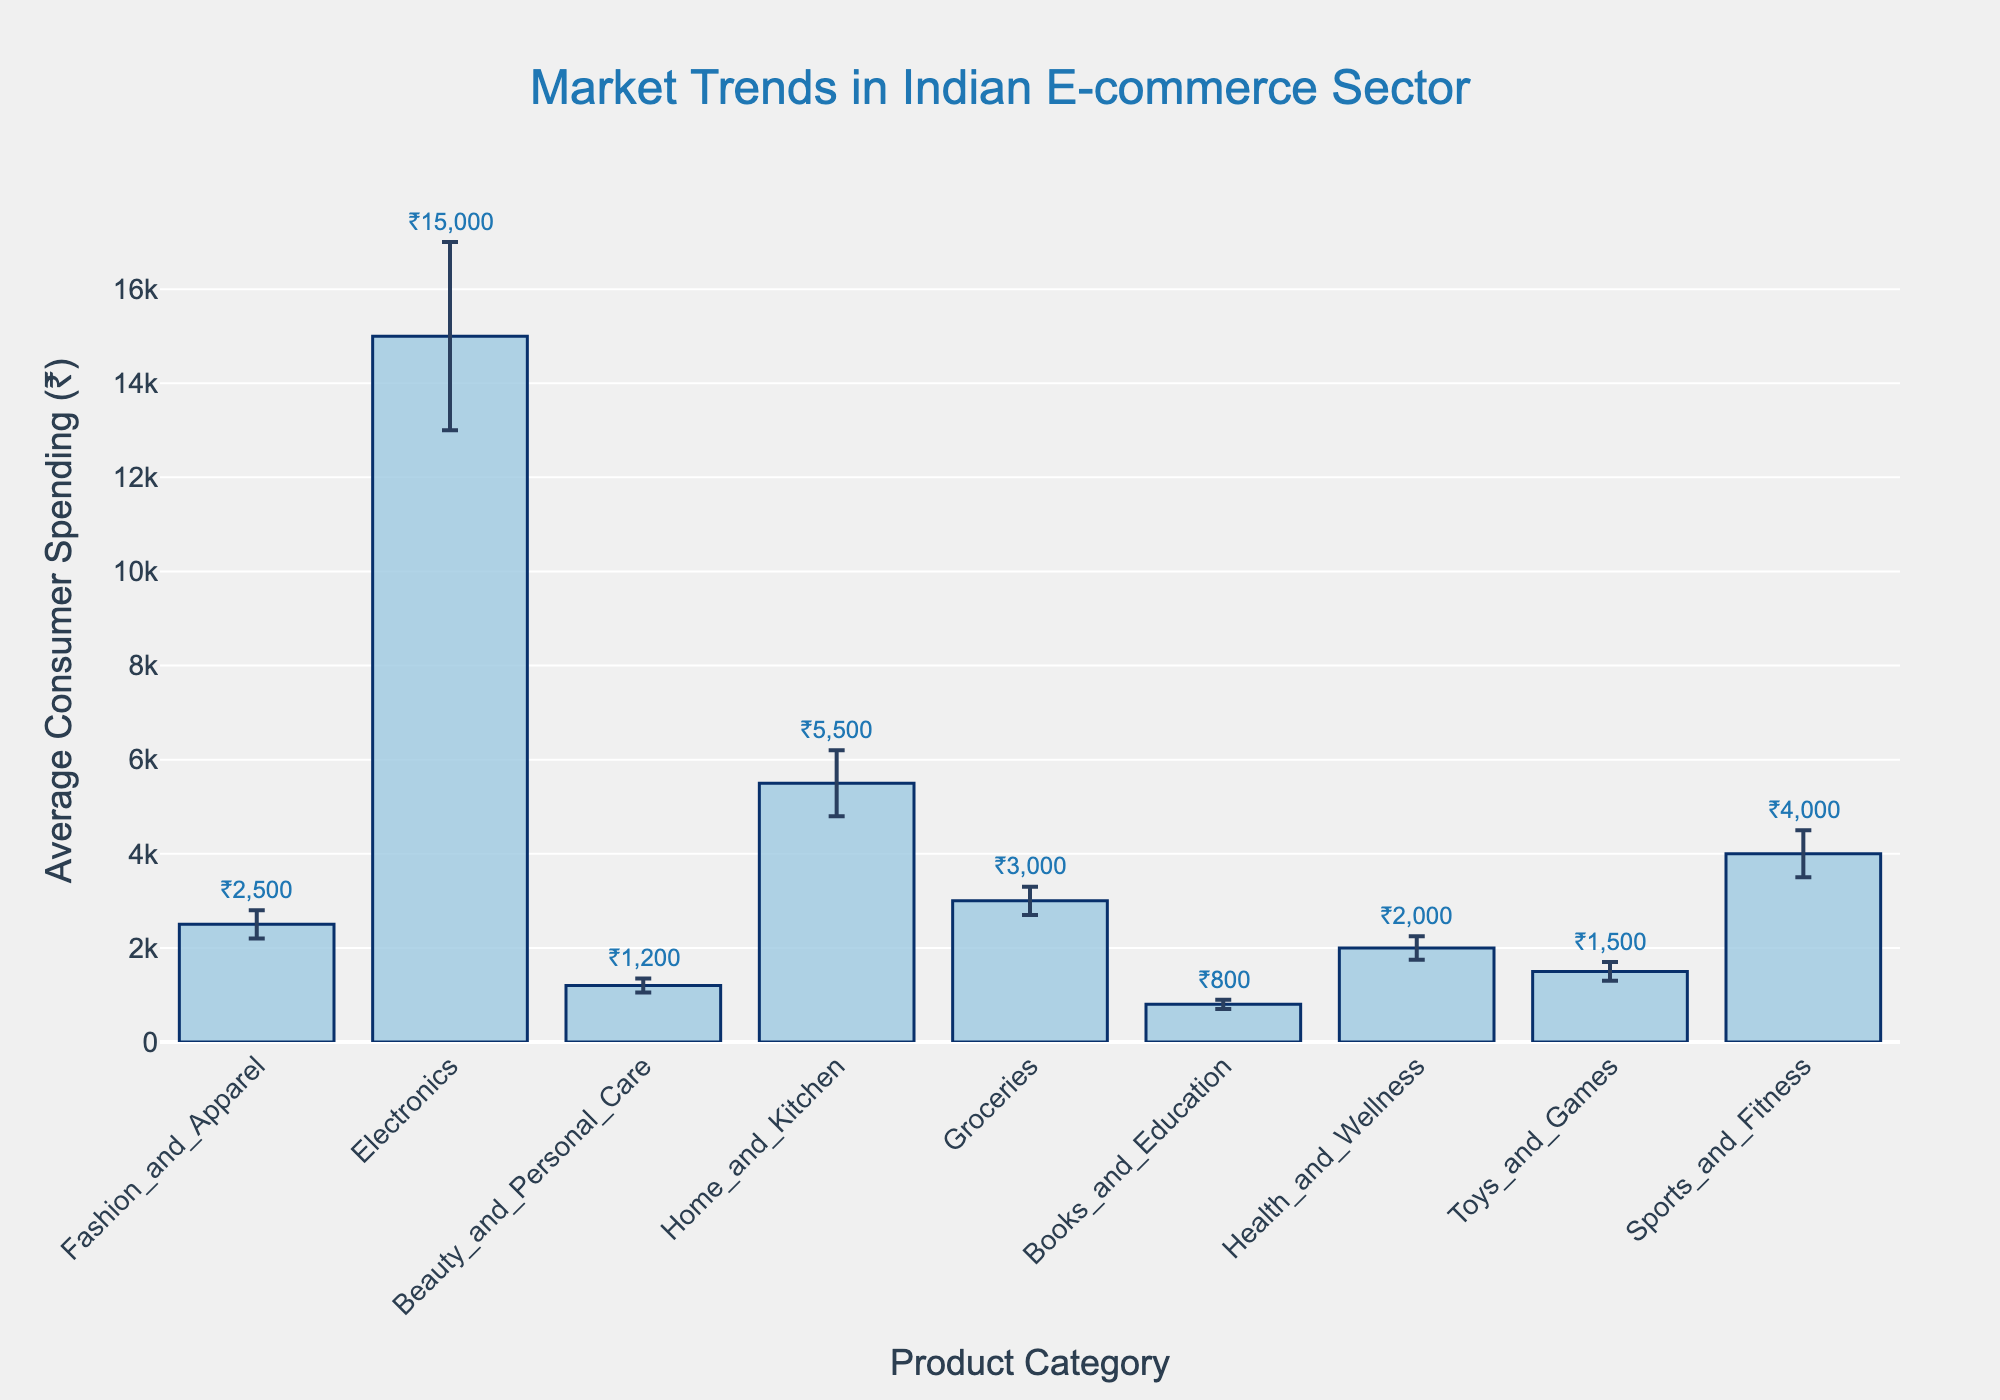What is the title of the plot? The title of the plot is positioned at the top center of the figure. It is given in a larger font size relative to other text elements in the figure.
Answer: Market Trends in Indian E-commerce Sector What is the average consumer spending for Electronics? The average consumer spending for each category is visually represented by the height of the bars. Locate the bar labeled 'Electronics' and read its height value, which is also annotated above the bar.
Answer: ₹15,000 Which category has the lowest average consumer spending? To find the category with the lowest average consumer spending, compare the heights of all the bars and identify the shortest one. It's also confirmed by the annotation above this bar.
Answer: Books and Education What is the combined average consumer spending for Fashion and Apparel and Groceries? First, identify the average consumer spending for Fashion and Apparel (₹2,500) and Groceries (₹3,000). Add these two values together: ₹2,500 + ₹3,000.
Answer: ₹5,500 Which category shows the highest variation in consumer spending? Variation in consumer spending is indicated by the length of the error bars. Locate the category with the longest error bar.
Answer: Electronics What is the difference in average consumer spending between Home and Kitchen and Health and Wellness? Identify the average consumer spending for Home and Kitchen (₹5,500) and Health and Wellness (₹2,000). Subtract the smaller value from the larger one: ₹5,500 - ₹2,000.
Answer: ₹3,500 Which two categories have nearly equal average consumer spending? Look for bars with similar heights and examine their values. Fashion and Apparel and Groceries both have close average consumer spending values (₹2,500 and ₹3,000, respectively).
Answer: Fashion and Apparel and Groceries What is the average consumer spending for Sports and Fitness, including its variation? Find the Sports and Fitness bar and read the average consumer spending value (₹4,000) along with its standard deviation as shown by the error bar (±₹500).
Answer: ₹4,000 ± ₹500 How does the average consumer spending for Health and Wellness compare with Beauty and Personal Care? Compare the average consumer spending for Health and Wellness (₹2,000) and Beauty and Personal Care (₹1,200). Determine which is greater and by how much.
Answer: Health and Wellness is higher by ₹800 What can you infer from the error bars shown on the plot? Error bars indicate the variation in consumer spending for each category. Longer error bars suggest higher variability, meaning consumers' spending greatly varies within that category. Shorter error bars suggest more consistent spending patterns.
Answer: Higher variability in spending for categories like Electronics and more consistent spending in categories like Beauty and Personal Care 